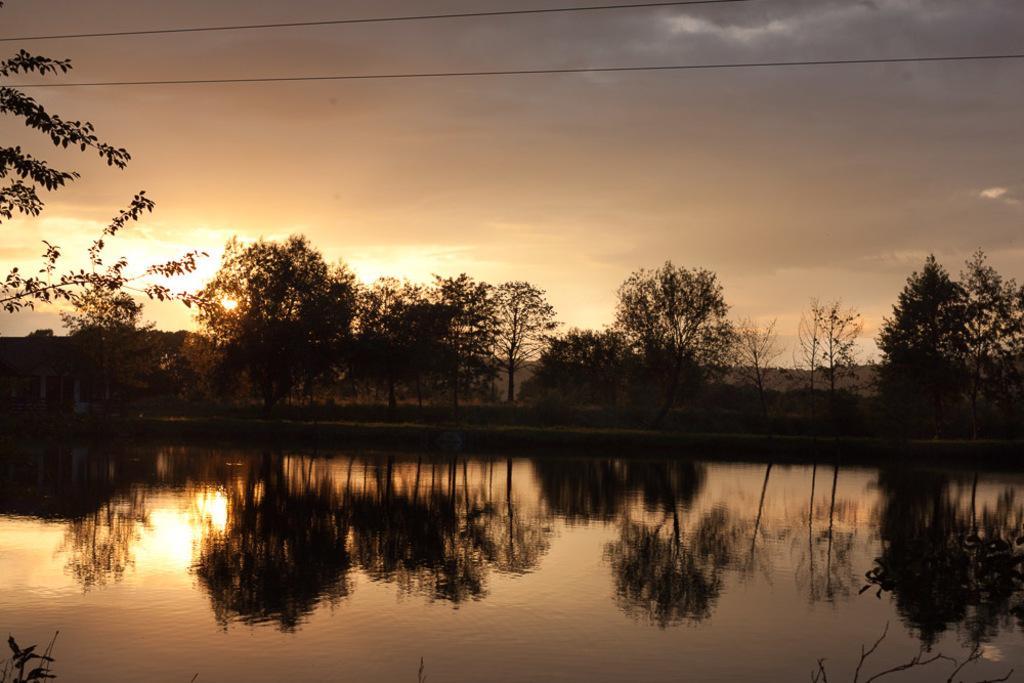Please provide a concise description of this image. In this image in the foreground there is water body. In the background there are trees,hills. The sky is cloudy. On the water body there is reflection of the background. 